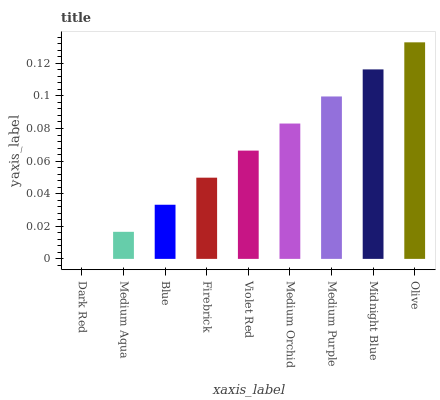Is Medium Aqua the minimum?
Answer yes or no. No. Is Medium Aqua the maximum?
Answer yes or no. No. Is Medium Aqua greater than Dark Red?
Answer yes or no. Yes. Is Dark Red less than Medium Aqua?
Answer yes or no. Yes. Is Dark Red greater than Medium Aqua?
Answer yes or no. No. Is Medium Aqua less than Dark Red?
Answer yes or no. No. Is Violet Red the high median?
Answer yes or no. Yes. Is Violet Red the low median?
Answer yes or no. Yes. Is Medium Purple the high median?
Answer yes or no. No. Is Midnight Blue the low median?
Answer yes or no. No. 